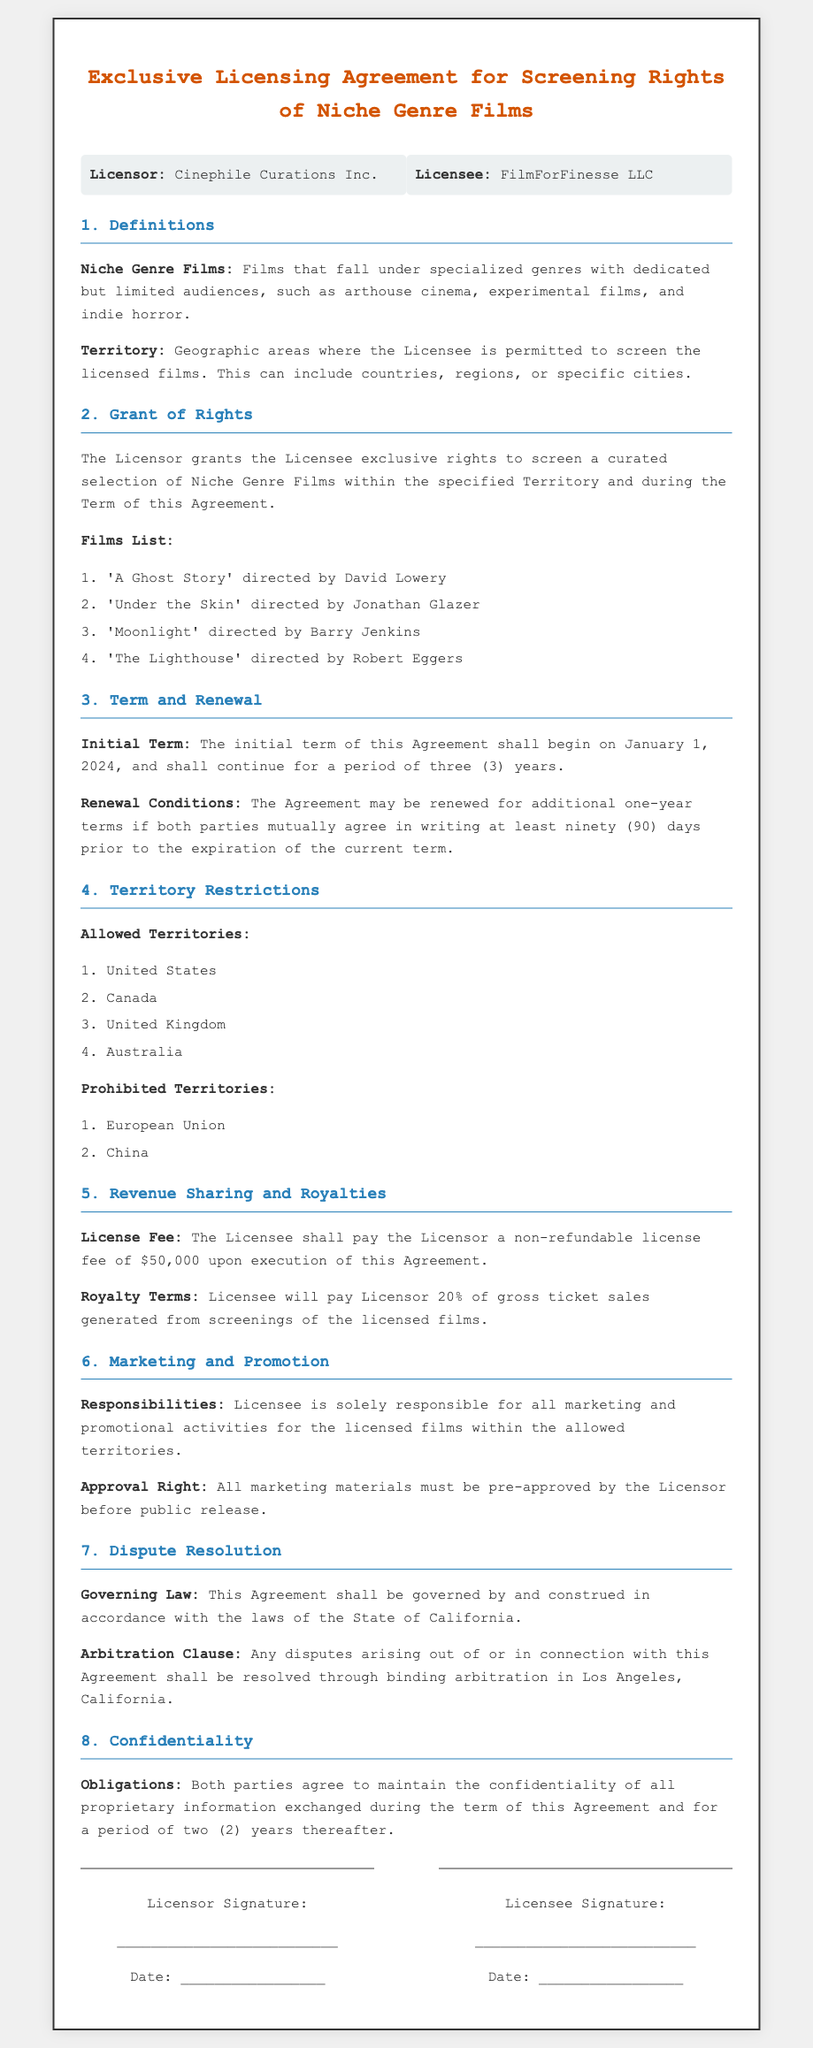What is the name of the Licensor? The Licensor is identified as Cinephile Curations Inc. in the document.
Answer: Cinephile Curations Inc What is the License Fee amount? The License Fee is explicitly stated as $50,000 in the document.
Answer: $50,000 What is the initial term duration of the agreement? The document mentions that the initial term lasts for three (3) years.
Answer: three years In which territory can the Licensee screen the films? The allowed territories where the Licensee can screen films are listed in the document.
Answer: United States, Canada, United Kingdom, Australia What percentage of gross ticket sales will the Licensee pay as royalties? The document specifies that the Licensee will pay Licensor 20% of gross ticket sales.
Answer: 20% What is required for renewal of the agreement? The conditions for renewal require mutual agreement in writing at least ninety (90) days prior to the expiration of the current term.
Answer: mutual agreement in writing Which law governs this agreement? The governing law specified in the document is that of the State of California.
Answer: State of California What is the confidentiality period after the agreement ends? The document states that confidentiality obligations last for two (2) years after the term.
Answer: two years 